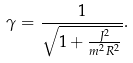Convert formula to latex. <formula><loc_0><loc_0><loc_500><loc_500>\gamma = \frac { 1 } { \sqrt { 1 + \frac { J ^ { 2 } } { m ^ { 2 } R ^ { 2 } } } } .</formula> 